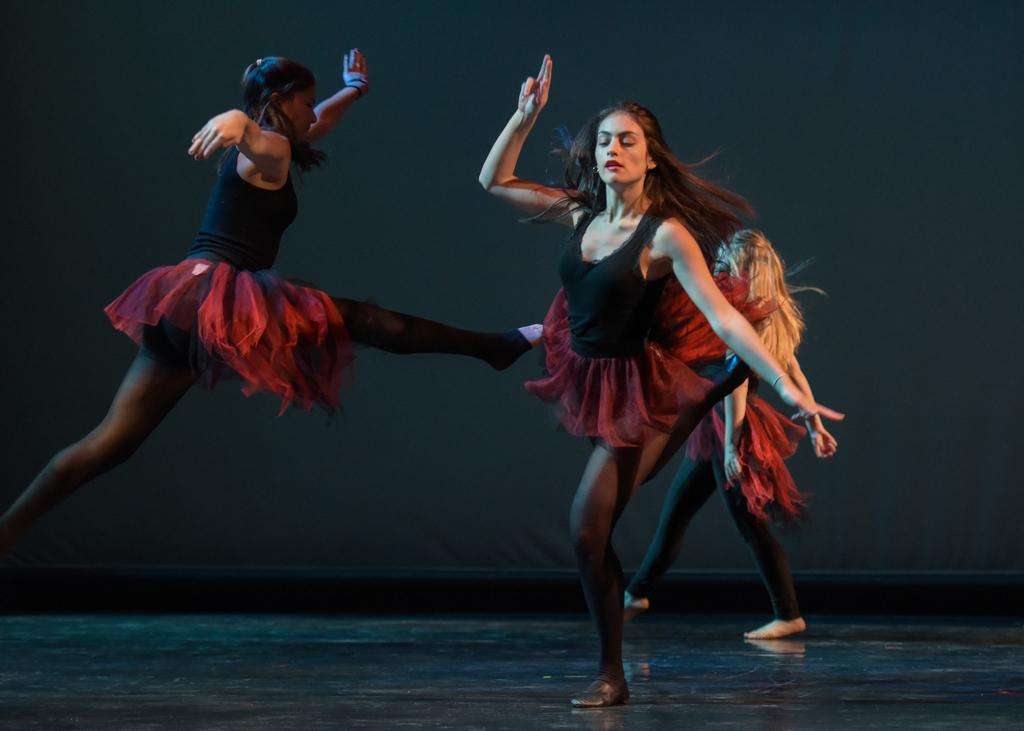How many people are in the image? There are three girls in the image. What are the girls doing in the image? The girls are dancing on the floor. What color is the background of the image? The background of the image is black. How many frogs can be seen hopping on the stick in the image? There are no frogs or sticks present in the image. 